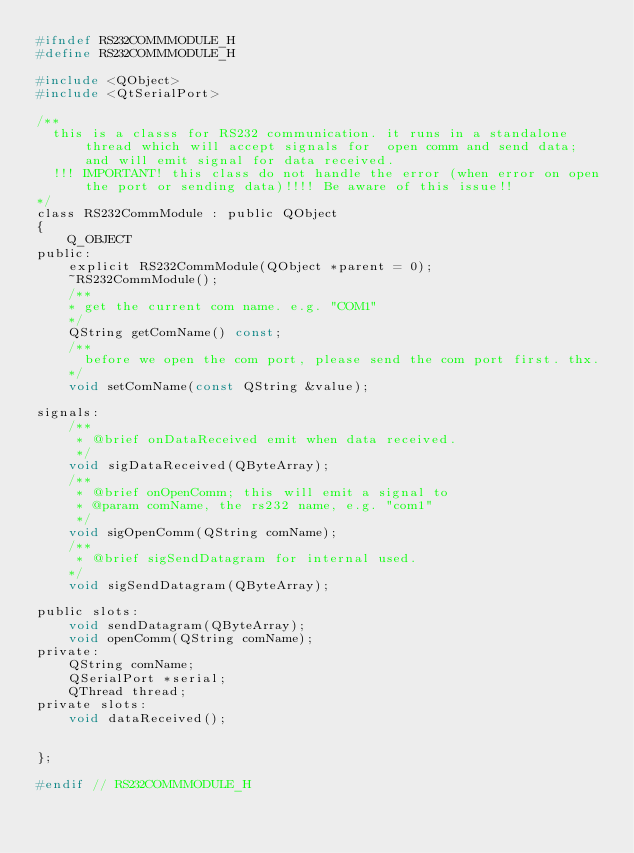Convert code to text. <code><loc_0><loc_0><loc_500><loc_500><_C_>#ifndef RS232COMMMODULE_H
#define RS232COMMMODULE_H

#include <QObject>
#include <QtSerialPort>

/**
  this is a classs for RS232 communication. it runs in a standalone thread which will accept signals for  open comm and send data; and will emit signal for data received. 
  !!! IMPORTANT! this class do not handle the error (when error on open the port or sending data)!!!! Be aware of this issue!!
*/
class RS232CommModule : public QObject
{
    Q_OBJECT
public:
    explicit RS232CommModule(QObject *parent = 0);
    ~RS232CommModule();
	/**
	* get the current com name. e.g. "COM1"
	*/
    QString getComName() const;
	/**
	  before we open the com port, please send the com port first. thx. 
	*/
    void setComName(const QString &value);

signals:
    /**
     * @brief onDataReceived emit when data received.
     */
    void sigDataReceived(QByteArray);
    /**
     * @brief onOpenComm; this will emit a signal to 
     * @param comName, the rs232 name, e.g. "com1"
     */
    void sigOpenComm(QString comName);
	/**
	 * @brief sigSendDatagram for internal used. 
	*/
    void sigSendDatagram(QByteArray);

public slots:
    void sendDatagram(QByteArray);
    void openComm(QString comName);
private:
    QString comName;
    QSerialPort *serial;
    QThread thread;
private slots:
    void dataReceived();


};

#endif // RS232COMMMODULE_H
</code> 